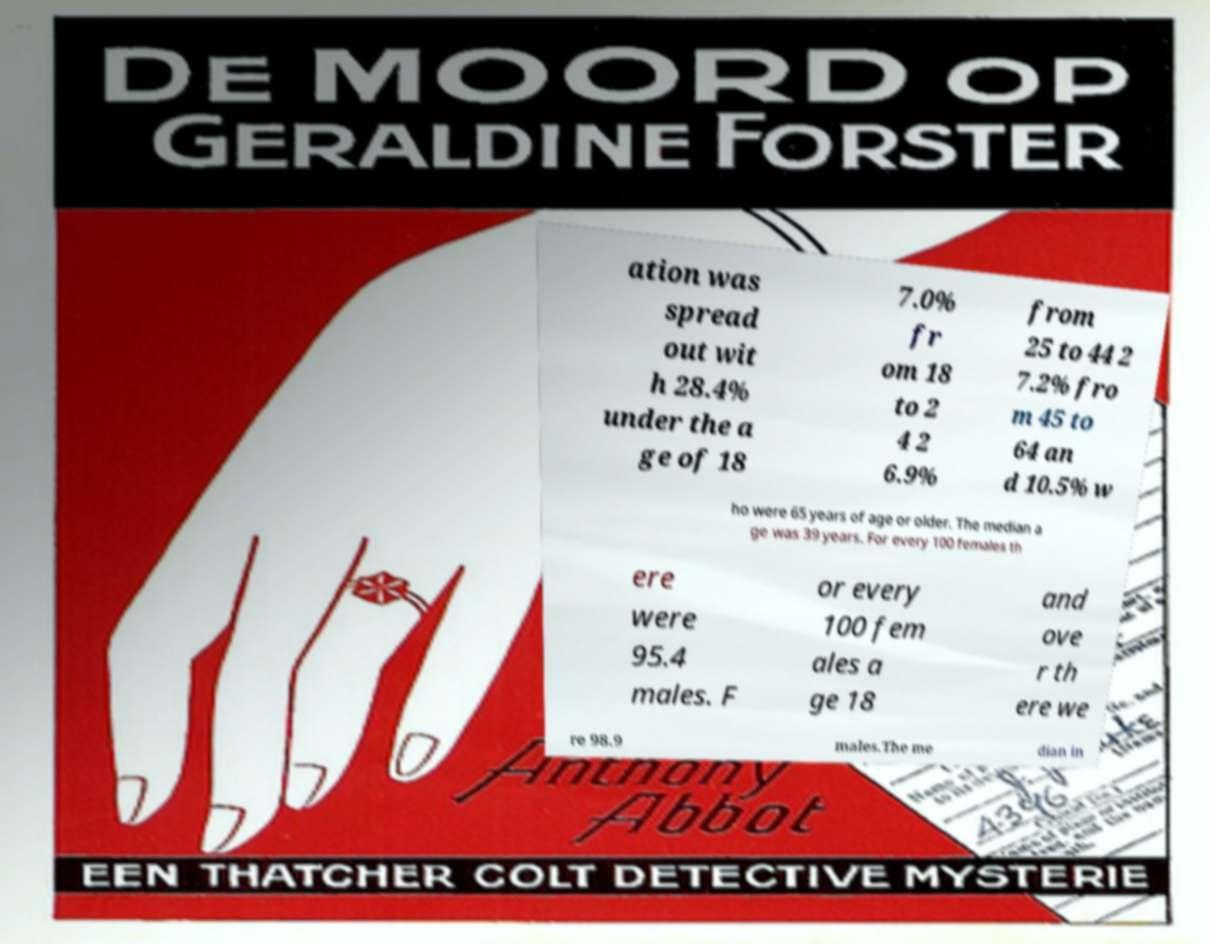Can you accurately transcribe the text from the provided image for me? ation was spread out wit h 28.4% under the a ge of 18 7.0% fr om 18 to 2 4 2 6.9% from 25 to 44 2 7.2% fro m 45 to 64 an d 10.5% w ho were 65 years of age or older. The median a ge was 39 years. For every 100 females th ere were 95.4 males. F or every 100 fem ales a ge 18 and ove r th ere we re 98.9 males.The me dian in 